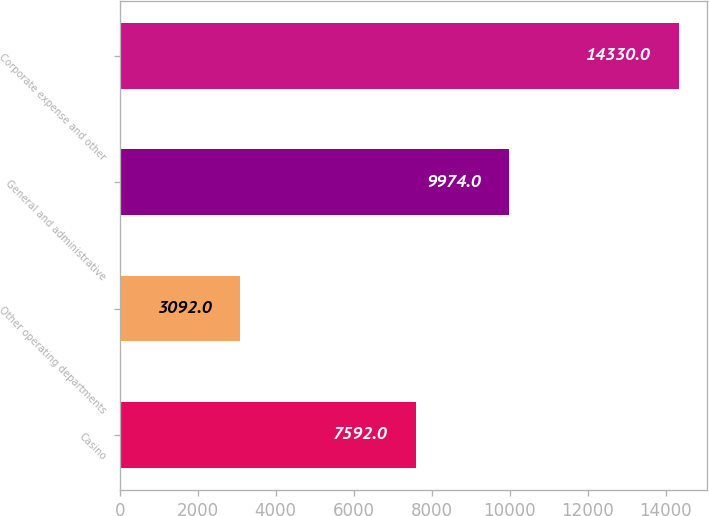<chart> <loc_0><loc_0><loc_500><loc_500><bar_chart><fcel>Casino<fcel>Other operating departments<fcel>General and administrative<fcel>Corporate expense and other<nl><fcel>7592<fcel>3092<fcel>9974<fcel>14330<nl></chart> 